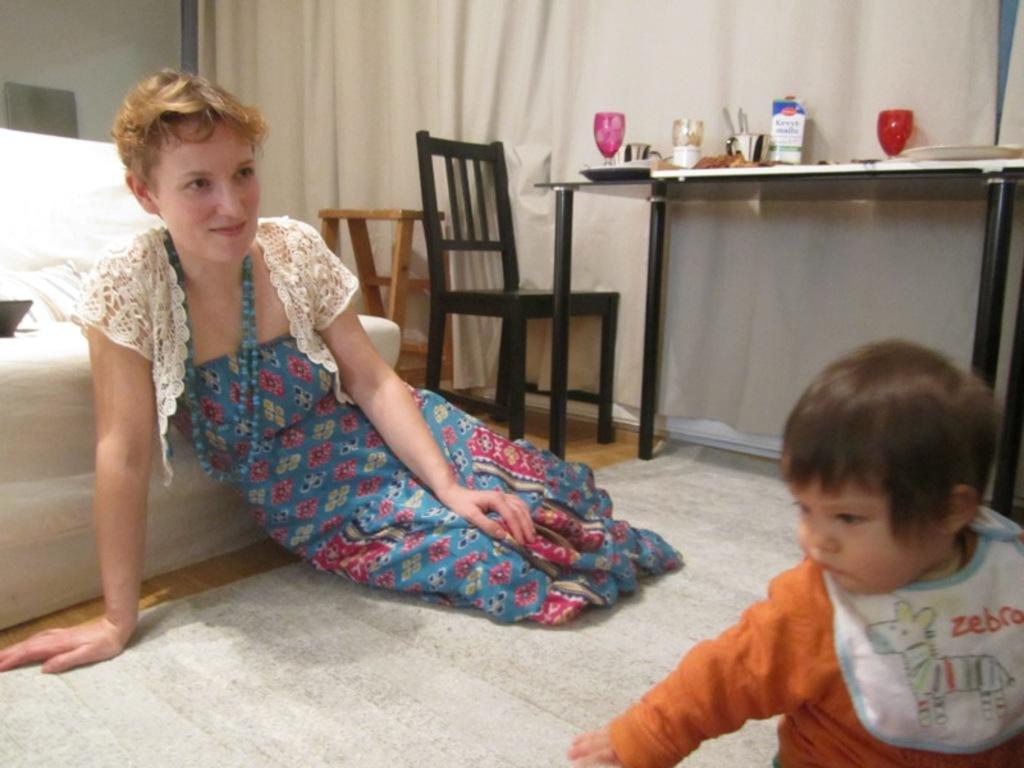<image>
Give a short and clear explanation of the subsequent image. Boy wearing a white bib that says the word ZEBRA on it. 